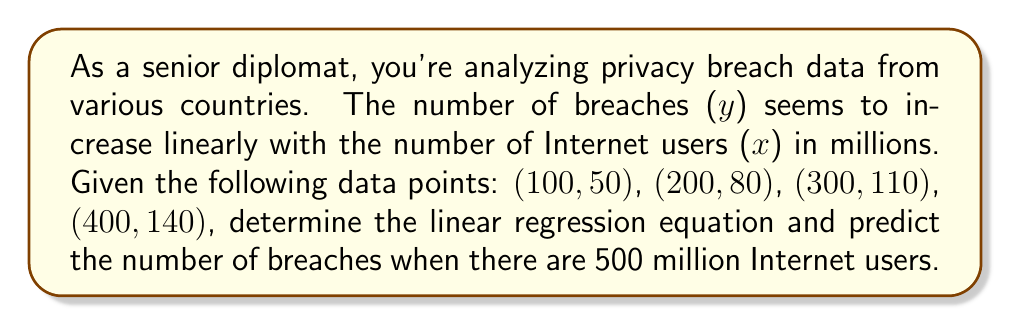Could you help me with this problem? To find the linear regression equation and make a prediction, we'll follow these steps:

1) The linear regression equation has the form $y = mx + b$, where $m$ is the slope and $b$ is the y-intercept.

2) To find $m$ and $b$, we'll use the following formulas:

   $m = \frac{n\sum xy - \sum x \sum y}{n\sum x^2 - (\sum x)^2}$

   $b = \frac{\sum y - m\sum x}{n}$

   where $n$ is the number of data points.

3) Let's calculate the necessary sums:
   
   $n = 4$
   $\sum x = 100 + 200 + 300 + 400 = 1000$
   $\sum y = 50 + 80 + 110 + 140 = 380$
   $\sum xy = (100)(50) + (200)(80) + (300)(110) + (400)(140) = 121000$
   $\sum x^2 = 100^2 + 200^2 + 300^2 + 400^2 = 300000$

4) Now, let's calculate $m$:

   $m = \frac{4(121000) - (1000)(380)}{4(300000) - (1000)^2} = \frac{484000 - 380000}{1200000 - 1000000} = \frac{104000}{200000} = 0.52$

5) Next, let's calculate $b$:

   $b = \frac{380 - 0.52(1000)}{4} = \frac{380 - 520}{4} = -35$

6) Therefore, our linear regression equation is:

   $y = 0.52x - 35$

7) To predict the number of breaches when there are 500 million Internet users, we substitute $x = 500$ into our equation:

   $y = 0.52(500) - 35 = 260 - 35 = 225$

Thus, we predict 225 breaches when there are 500 million Internet users.
Answer: $y = 0.52x - 35$; 225 breaches 